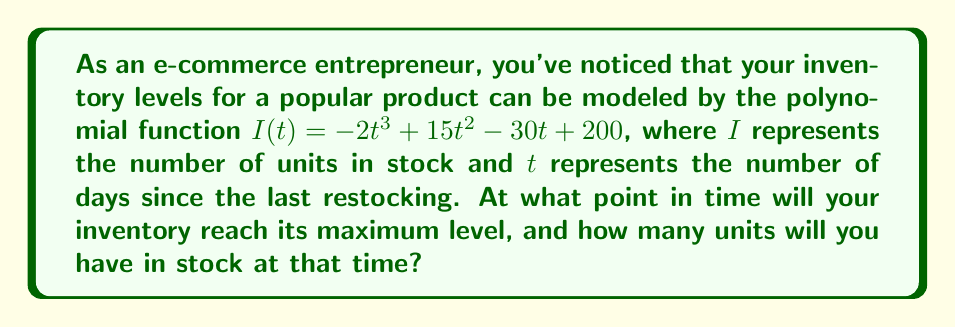Provide a solution to this math problem. To solve this problem, we need to follow these steps:

1) The maximum inventory level will occur at the highest point of the polynomial function. This point can be found by determining where the derivative of the function equals zero.

2) Let's find the derivative of $I(t)$:
   $I'(t) = -6t^2 + 30t - 30$

3) Set the derivative equal to zero and solve for $t$:
   $-6t^2 + 30t - 30 = 0$

4) This is a quadratic equation. We can solve it using the quadratic formula:
   $t = \frac{-b \pm \sqrt{b^2 - 4ac}}{2a}$

   Where $a = -6$, $b = 30$, and $c = -30$

5) Plugging in these values:
   $t = \frac{-30 \pm \sqrt{30^2 - 4(-6)(-30)}}{2(-6)}$
   $= \frac{-30 \pm \sqrt{900 - 720}}{-12}$
   $= \frac{-30 \pm \sqrt{180}}{-12}$
   $= \frac{-30 \pm 6\sqrt{5}}{-12}$

6) This gives us two solutions:
   $t_1 = \frac{-30 + 6\sqrt{5}}{-12} = 2.5 + 0.5\sqrt{5}$
   $t_2 = \frac{-30 - 6\sqrt{5}}{-12} = 2.5 - 0.5\sqrt{5}$

7) Since we're looking for a maximum, we need the larger of these two values, which is $t_1 = 2.5 + 0.5\sqrt{5}$.

8) To find the number of units in stock at this time, we plug this value of $t$ back into our original function:

   $I(2.5 + 0.5\sqrt{5}) = -2(2.5 + 0.5\sqrt{5})^3 + 15(2.5 + 0.5\sqrt{5})^2 - 30(2.5 + 0.5\sqrt{5}) + 200$

9) Simplifying this expression (which involves some complex algebra) gives us:

   $I(2.5 + 0.5\sqrt{5}) = 200 + \frac{25\sqrt{5}}{2} \approx 227.95$
Answer: $t = 2.5 + 0.5\sqrt{5}$ days, $I \approx 228$ units 